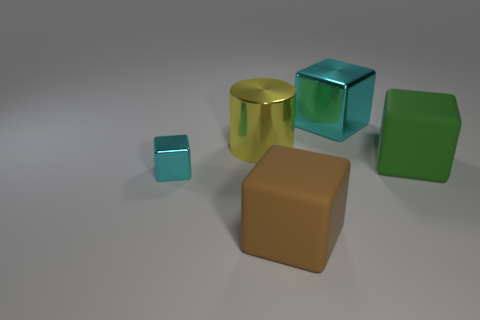How many cyan blocks have the same size as the green rubber cube?
Provide a short and direct response. 1. The other thing that is the same color as the tiny object is what shape?
Provide a short and direct response. Cube. Is there a metal block?
Provide a short and direct response. Yes. There is a large rubber thing that is on the left side of the green cube; does it have the same shape as the yellow metal thing behind the large green rubber cube?
Your answer should be compact. No. What number of large things are red shiny cubes or brown rubber things?
Provide a short and direct response. 1. There is a brown object that is the same material as the green block; what is its shape?
Your response must be concise. Cube. Is the tiny thing the same shape as the yellow metal thing?
Your response must be concise. No. The tiny metallic object has what color?
Provide a short and direct response. Cyan. What number of things are either small yellow rubber balls or tiny shiny things?
Make the answer very short. 1. Is the number of big yellow metal cylinders on the left side of the tiny cyan block less than the number of tiny things?
Your answer should be very brief. Yes. 